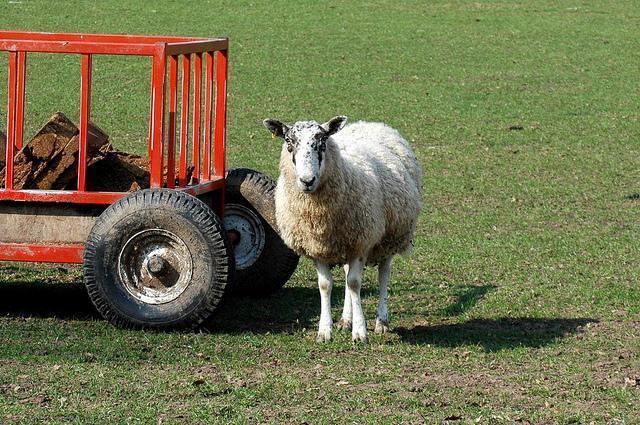Does the image validate the caption "The truck is next to the sheep."?
Answer yes or no. Yes. Does the image validate the caption "The sheep is next to the truck."?
Answer yes or no. Yes. 